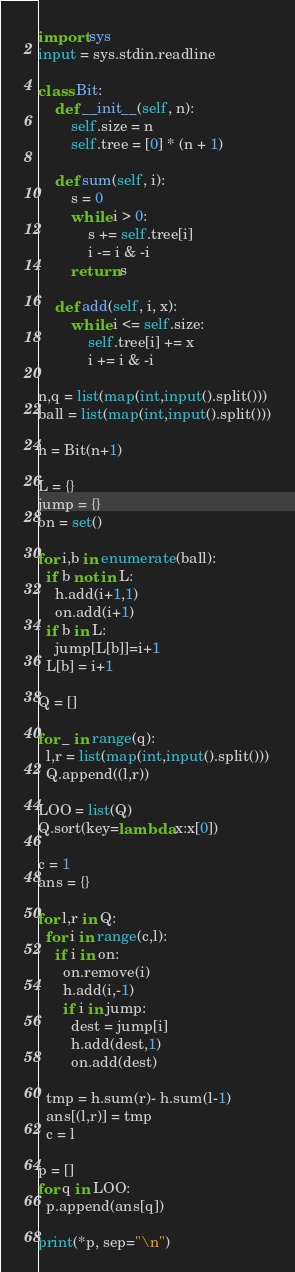<code> <loc_0><loc_0><loc_500><loc_500><_Python_>import sys
input = sys.stdin.readline
 
class Bit:
    def __init__(self, n):
        self.size = n
        self.tree = [0] * (n + 1)
 
    def sum(self, i):
        s = 0
        while i > 0:
            s += self.tree[i]
            i -= i & -i
        return s
 
    def add(self, i, x):
        while i <= self.size:
            self.tree[i] += x
            i += i & -i
 
n,q = list(map(int,input().split()))
ball = list(map(int,input().split()))
 
h = Bit(n+1)

L = {}
jump = {}
on = set()

for i,b in enumerate(ball):
  if b not in L:
    h.add(i+1,1)
    on.add(i+1)
  if b in L:
    jump[L[b]]=i+1
  L[b] = i+1

Q = []
 
for _ in range(q):
  l,r = list(map(int,input().split()))
  Q.append((l,r))
  
LOO = list(Q)
Q.sort(key=lambda x:x[0])

c = 1
ans = {}

for l,r in Q:
  for i in range(c,l):
    if i in on:
      on.remove(i)
      h.add(i,-1)
      if i in jump:
        dest = jump[i]
        h.add(dest,1)
        on.add(dest)

  tmp = h.sum(r)- h.sum(l-1)
  ans[(l,r)] = tmp
  c = l

p = []
for q in LOO:
  p.append(ans[q])
  
print(*p, sep="\n")</code> 